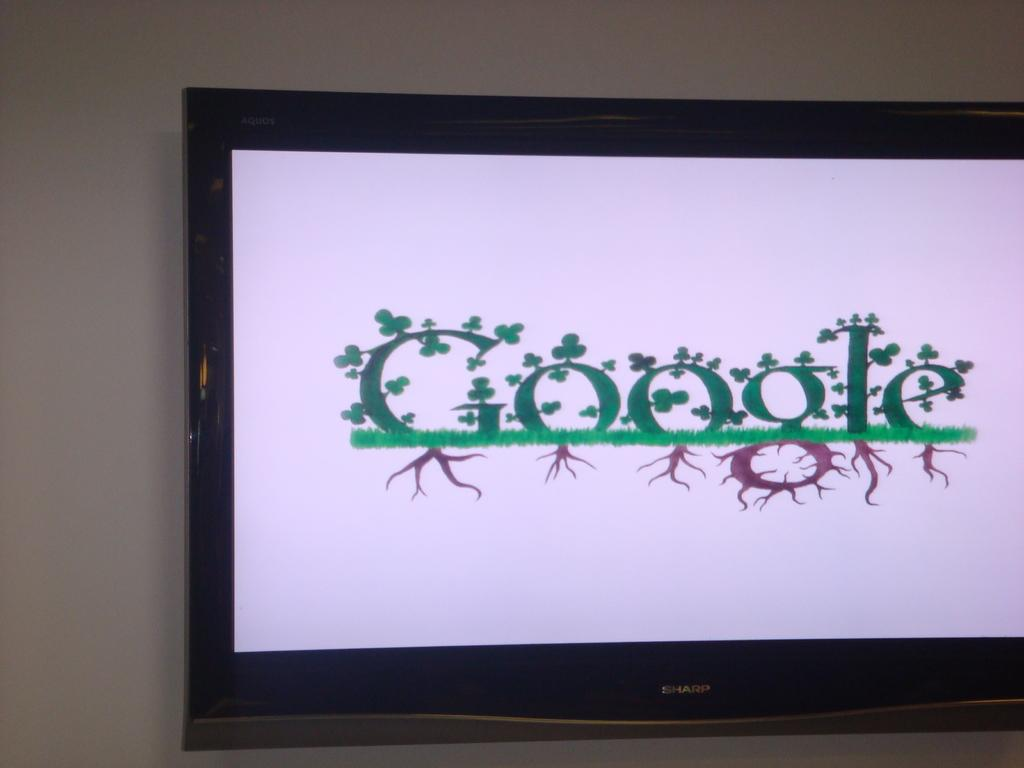Provide a one-sentence caption for the provided image. A monitor shows the Google logo which shamrocks on the work and roots below it. 